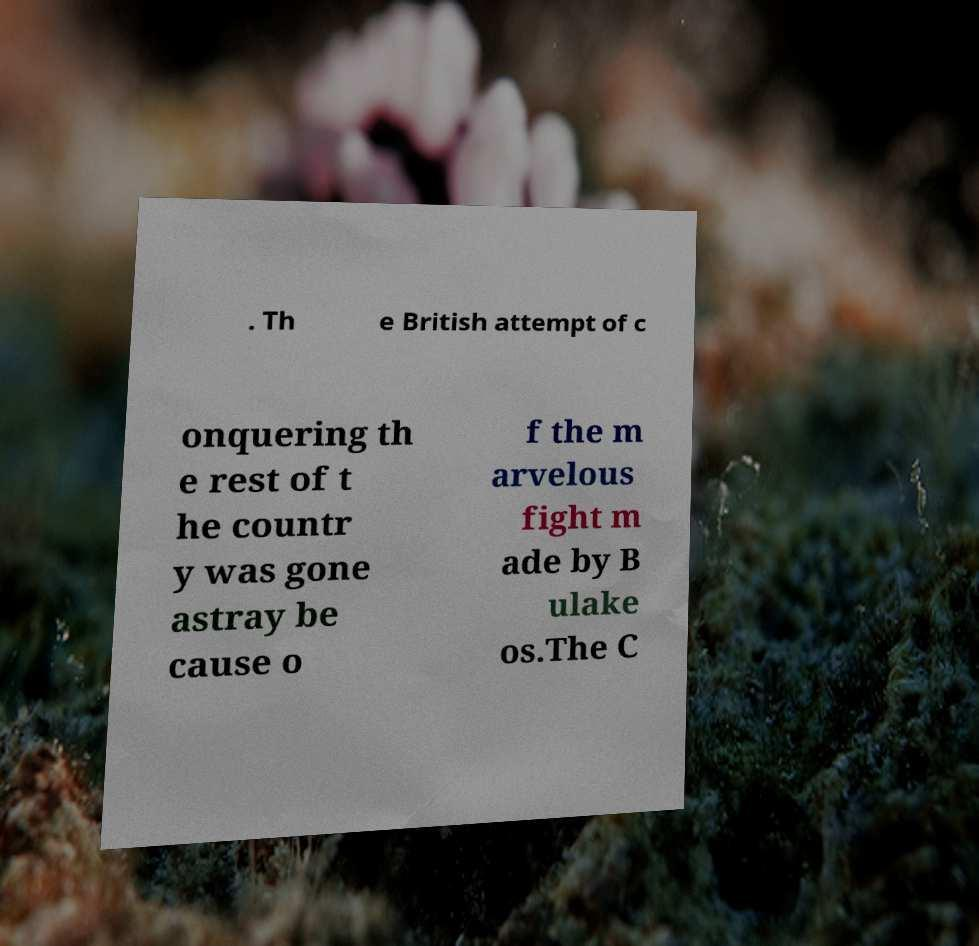Please read and relay the text visible in this image. What does it say? . Th e British attempt of c onquering th e rest of t he countr y was gone astray be cause o f the m arvelous fight m ade by B ulake os.The C 